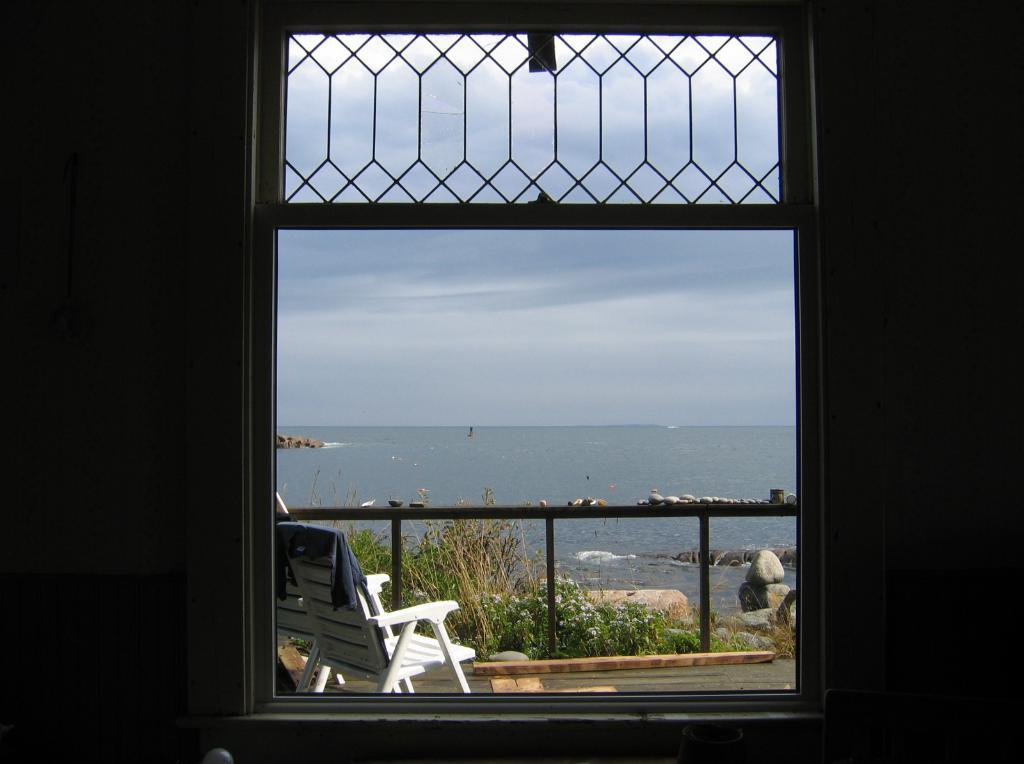What can be seen in the image that provides a view of the outdoors? There is a window in the image that provides a view of the outdoors. What is located outside the window? There is a white chair outside the window. What else can be seen in the image that is related to the outdoor environment? There is water visible in the image. What is visible at the top of the image? The sky is visible at the top of the image. How many friends are sitting on the white chair in the image? There are no friends visible in the image; only the white chair is present outside the window. Is there a chicken visible in the image? There is no chicken present in the image. 